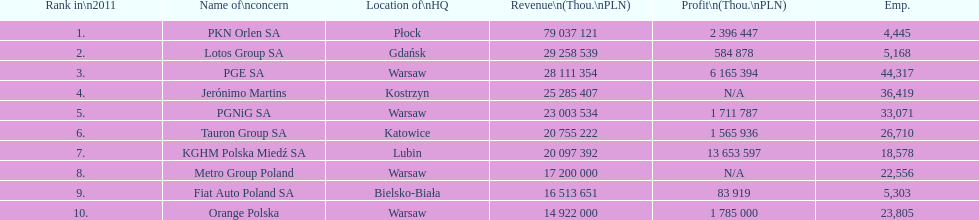Parse the full table. {'header': ['Rank in\\n2011', 'Name of\\nconcern', 'Location of\\nHQ', 'Revenue\\n(Thou.\\nPLN)', 'Profit\\n(Thou.\\nPLN)', 'Emp.'], 'rows': [['1.', 'PKN Orlen SA', 'Płock', '79 037 121', '2 396 447', '4,445'], ['2.', 'Lotos Group SA', 'Gdańsk', '29 258 539', '584 878', '5,168'], ['3.', 'PGE SA', 'Warsaw', '28 111 354', '6 165 394', '44,317'], ['4.', 'Jerónimo Martins', 'Kostrzyn', '25 285 407', 'N/A', '36,419'], ['5.', 'PGNiG SA', 'Warsaw', '23 003 534', '1 711 787', '33,071'], ['6.', 'Tauron Group SA', 'Katowice', '20 755 222', '1 565 936', '26,710'], ['7.', 'KGHM Polska Miedź SA', 'Lubin', '20 097 392', '13 653 597', '18,578'], ['8.', 'Metro Group Poland', 'Warsaw', '17 200 000', 'N/A', '22,556'], ['9.', 'Fiat Auto Poland SA', 'Bielsko-Biała', '16 513 651', '83 919', '5,303'], ['10.', 'Orange Polska', 'Warsaw', '14 922 000', '1 785 000', '23,805']]} What company is the only one with a revenue greater than 75,000,000 thou. pln? PKN Orlen SA. 